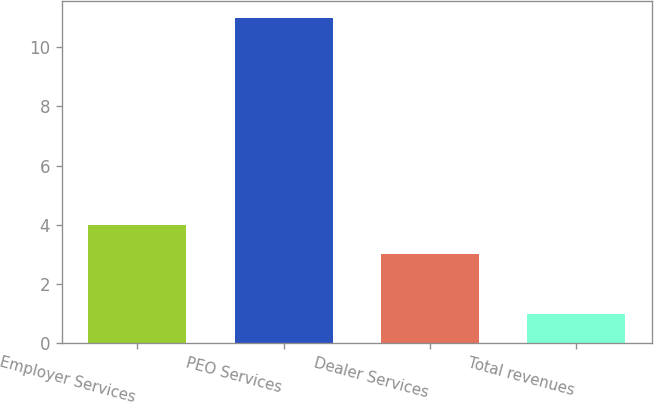Convert chart. <chart><loc_0><loc_0><loc_500><loc_500><bar_chart><fcel>Employer Services<fcel>PEO Services<fcel>Dealer Services<fcel>Total revenues<nl><fcel>4<fcel>11<fcel>3<fcel>1<nl></chart> 